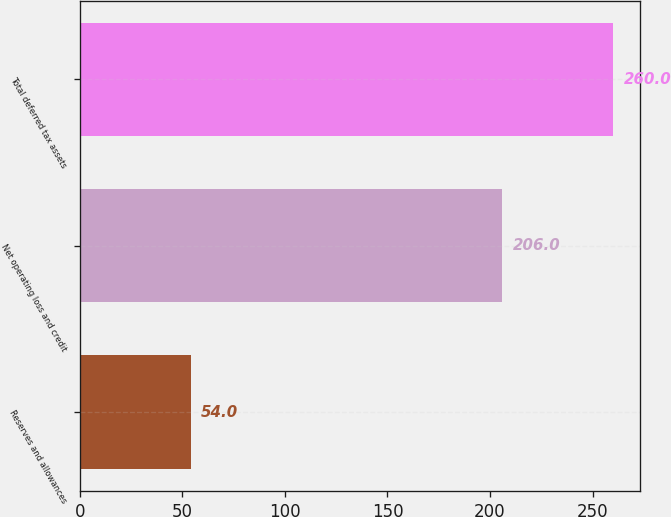<chart> <loc_0><loc_0><loc_500><loc_500><bar_chart><fcel>Reserves and allowances<fcel>Net operating loss and credit<fcel>Total deferred tax assets<nl><fcel>54<fcel>206<fcel>260<nl></chart> 